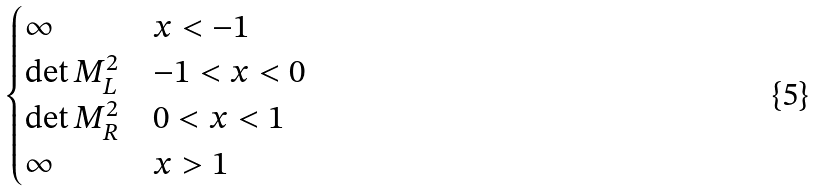Convert formula to latex. <formula><loc_0><loc_0><loc_500><loc_500>\begin{cases} \infty & x < - 1 \\ \det M _ { L } ^ { 2 } & - 1 < x < 0 \\ \det M _ { R } ^ { 2 } & 0 < x < 1 \\ \infty & x > 1 \end{cases}</formula> 